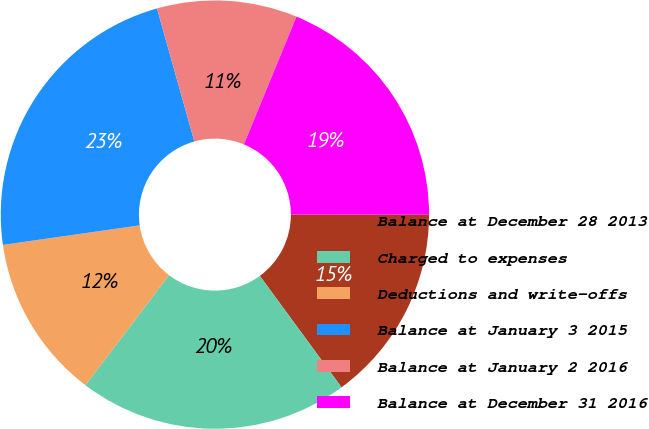Convert chart to OTSL. <chart><loc_0><loc_0><loc_500><loc_500><pie_chart><fcel>Balance at December 28 2013<fcel>Charged to expenses<fcel>Deductions and write-offs<fcel>Balance at January 3 2015<fcel>Balance at January 2 2016<fcel>Balance at December 31 2016<nl><fcel>14.92%<fcel>20.4%<fcel>12.41%<fcel>22.9%<fcel>10.58%<fcel>18.79%<nl></chart> 